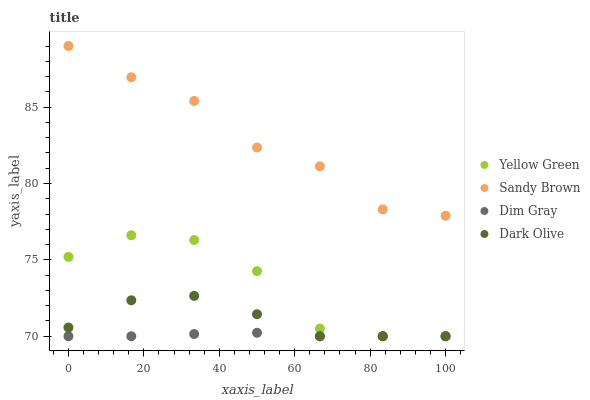Does Dim Gray have the minimum area under the curve?
Answer yes or no. Yes. Does Sandy Brown have the maximum area under the curve?
Answer yes or no. Yes. Does Sandy Brown have the minimum area under the curve?
Answer yes or no. No. Does Dim Gray have the maximum area under the curve?
Answer yes or no. No. Is Dim Gray the smoothest?
Answer yes or no. Yes. Is Yellow Green the roughest?
Answer yes or no. Yes. Is Sandy Brown the smoothest?
Answer yes or no. No. Is Sandy Brown the roughest?
Answer yes or no. No. Does Dark Olive have the lowest value?
Answer yes or no. Yes. Does Sandy Brown have the lowest value?
Answer yes or no. No. Does Sandy Brown have the highest value?
Answer yes or no. Yes. Does Dim Gray have the highest value?
Answer yes or no. No. Is Dark Olive less than Sandy Brown?
Answer yes or no. Yes. Is Sandy Brown greater than Dark Olive?
Answer yes or no. Yes. Does Dark Olive intersect Yellow Green?
Answer yes or no. Yes. Is Dark Olive less than Yellow Green?
Answer yes or no. No. Is Dark Olive greater than Yellow Green?
Answer yes or no. No. Does Dark Olive intersect Sandy Brown?
Answer yes or no. No. 